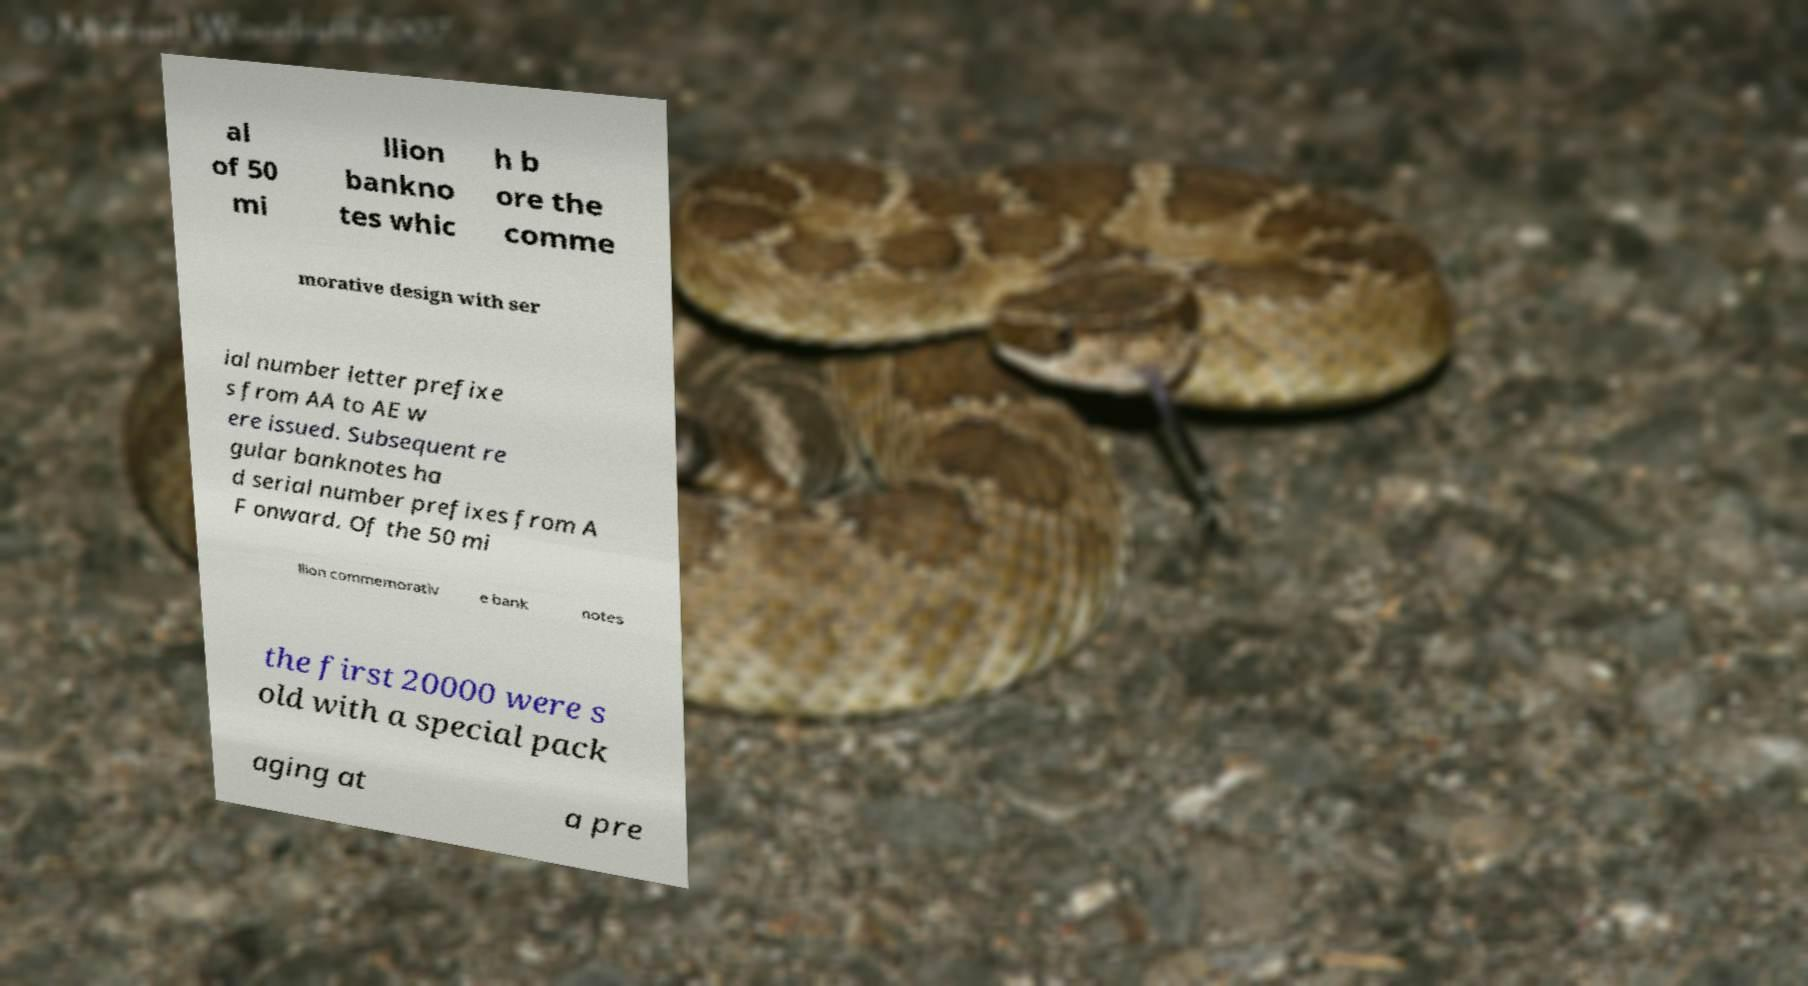Can you read and provide the text displayed in the image?This photo seems to have some interesting text. Can you extract and type it out for me? al of 50 mi llion bankno tes whic h b ore the comme morative design with ser ial number letter prefixe s from AA to AE w ere issued. Subsequent re gular banknotes ha d serial number prefixes from A F onward. Of the 50 mi llion commemorativ e bank notes the first 20000 were s old with a special pack aging at a pre 